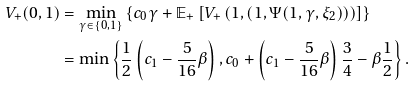Convert formula to latex. <formula><loc_0><loc_0><loc_500><loc_500>V _ { + } ( 0 , 1 ) & = \min _ { \gamma \in \{ 0 , 1 \} } \left \{ c _ { 0 } \gamma + \mathbb { E } _ { + } \left [ V _ { + } \left ( 1 , ( 1 , \Psi ( 1 , \gamma , \xi _ { 2 } ) ) \right ) \right ] \right \} \\ & = \min \left \{ \frac { 1 } { 2 } \left ( c _ { 1 } - \frac { 5 } { 1 6 } \beta \right ) , c _ { 0 } + \left ( c _ { 1 } - \frac { 5 } { 1 6 } \beta \right ) \frac { 3 } { 4 } - \beta \frac { 1 } { 2 } \right \} .</formula> 